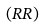<formula> <loc_0><loc_0><loc_500><loc_500>( R R )</formula> 